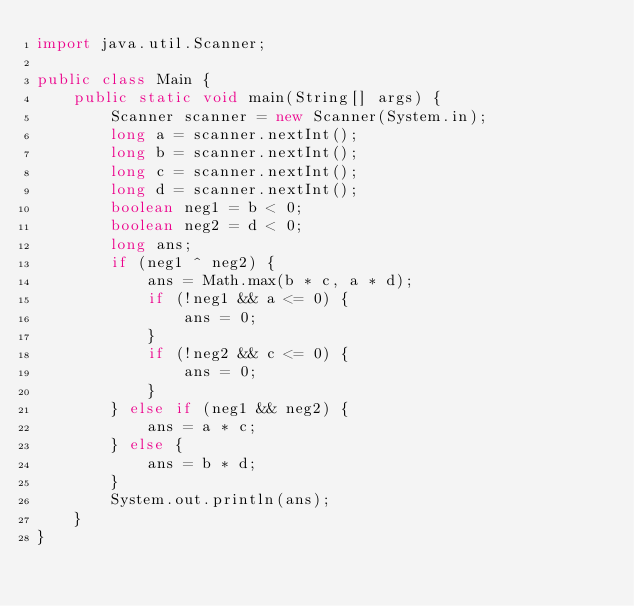Convert code to text. <code><loc_0><loc_0><loc_500><loc_500><_Java_>import java.util.Scanner;

public class Main {
    public static void main(String[] args) {
        Scanner scanner = new Scanner(System.in);
        long a = scanner.nextInt();
        long b = scanner.nextInt();
        long c = scanner.nextInt();
        long d = scanner.nextInt();
        boolean neg1 = b < 0;
        boolean neg2 = d < 0;
        long ans;
        if (neg1 ^ neg2) {
            ans = Math.max(b * c, a * d);
            if (!neg1 && a <= 0) {
                ans = 0;
            }
            if (!neg2 && c <= 0) {
                ans = 0;
            }
        } else if (neg1 && neg2) {
            ans = a * c;
        } else {
            ans = b * d;
        }
        System.out.println(ans);
    }
}</code> 